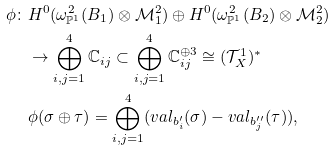<formula> <loc_0><loc_0><loc_500><loc_500>\phi \colon & H ^ { 0 } ( \omega _ { \mathbb { P } ^ { 1 } } ^ { 2 } ( B _ { 1 } ) \otimes \mathcal { M } _ { 1 } ^ { 2 } ) \oplus H ^ { 0 } ( \omega _ { \mathbb { P } ^ { 1 } } ^ { 2 } ( B _ { 2 } ) \otimes \mathcal { M } _ { 2 } ^ { 2 } ) \\ & \to \bigoplus _ { i , j = 1 } ^ { 4 } \mathbb { C } _ { i j } \subset \bigoplus _ { i , j = 1 } ^ { 4 } \mathbb { C } _ { i j } ^ { \oplus 3 } \cong ( \mathcal { T } _ { X } ^ { 1 } ) ^ { \ast } \\ & \phi ( \sigma \oplus \tau ) = \bigoplus _ { i , j = 1 } ^ { 4 } ( v a l _ { b _ { i } ^ { \prime } } ( \sigma ) - v a l _ { b _ { j } ^ { \prime \prime } } ( \tau ) ) ,</formula> 